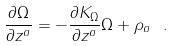Convert formula to latex. <formula><loc_0><loc_0><loc_500><loc_500>\frac { \partial \Omega } { \partial z ^ { a } } = - \frac { \partial K _ { \Omega } } { \partial z ^ { a } } \Omega + \rho _ { a } \ .</formula> 